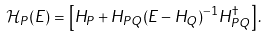<formula> <loc_0><loc_0><loc_500><loc_500>\mathcal { H } _ { P } ( E ) = \left [ H _ { P } + H _ { P Q } ( E - H _ { Q } ) ^ { - 1 } H _ { P Q } ^ { \dagger } \right ] .</formula> 